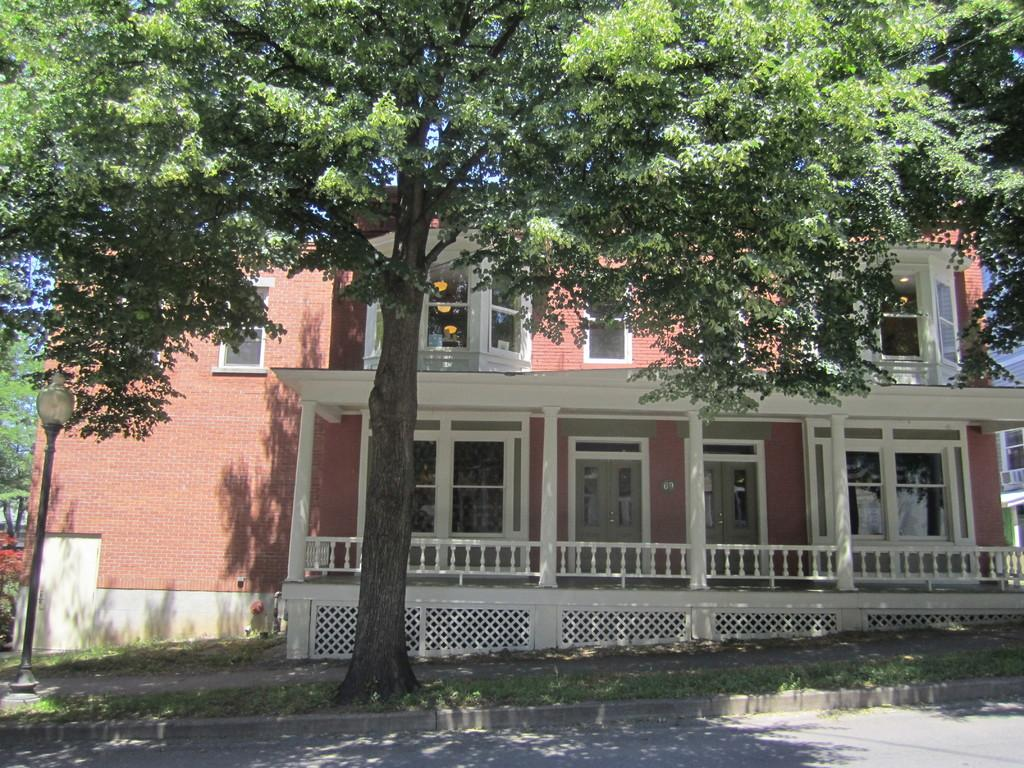What type of structure is visible in the image? There is a building in the image. What type of vegetation can be seen in the image? There is grass and trees in the image. What object is present in the image that might be used for support or display? There is a pole in the image. What type of illumination is present in the image? There is a light in the image. What type of vessel is being used to cook food in the image? There is no vessel or cooking activity present in the image. What type of pan is visible in the image? There is no pan present in the image. 